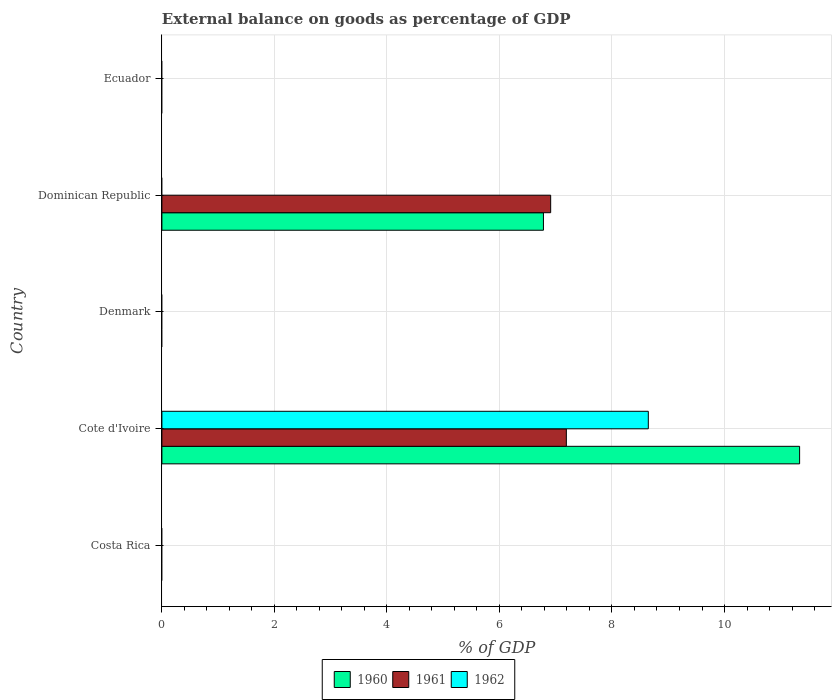How many different coloured bars are there?
Keep it short and to the point. 3. Are the number of bars per tick equal to the number of legend labels?
Ensure brevity in your answer.  No. What is the label of the 1st group of bars from the top?
Provide a succinct answer. Ecuador. In how many cases, is the number of bars for a given country not equal to the number of legend labels?
Your answer should be compact. 4. Across all countries, what is the maximum external balance on goods as percentage of GDP in 1961?
Ensure brevity in your answer.  7.19. Across all countries, what is the minimum external balance on goods as percentage of GDP in 1962?
Offer a very short reply. 0. In which country was the external balance on goods as percentage of GDP in 1961 maximum?
Provide a short and direct response. Cote d'Ivoire. What is the total external balance on goods as percentage of GDP in 1962 in the graph?
Your answer should be compact. 8.65. What is the difference between the external balance on goods as percentage of GDP in 1960 in Cote d'Ivoire and that in Dominican Republic?
Make the answer very short. 4.55. What is the difference between the external balance on goods as percentage of GDP in 1962 in Ecuador and the external balance on goods as percentage of GDP in 1961 in Dominican Republic?
Offer a terse response. -6.91. What is the average external balance on goods as percentage of GDP in 1962 per country?
Give a very brief answer. 1.73. What is the difference between the external balance on goods as percentage of GDP in 1962 and external balance on goods as percentage of GDP in 1961 in Cote d'Ivoire?
Provide a succinct answer. 1.46. In how many countries, is the external balance on goods as percentage of GDP in 1962 greater than 8 %?
Make the answer very short. 1. What is the difference between the highest and the lowest external balance on goods as percentage of GDP in 1960?
Your response must be concise. 11.34. How many bars are there?
Keep it short and to the point. 5. How many countries are there in the graph?
Provide a succinct answer. 5. Does the graph contain any zero values?
Keep it short and to the point. Yes. Does the graph contain grids?
Give a very brief answer. Yes. How are the legend labels stacked?
Provide a short and direct response. Horizontal. What is the title of the graph?
Provide a short and direct response. External balance on goods as percentage of GDP. Does "1992" appear as one of the legend labels in the graph?
Offer a terse response. No. What is the label or title of the X-axis?
Your response must be concise. % of GDP. What is the % of GDP in 1960 in Costa Rica?
Your response must be concise. 0. What is the % of GDP in 1962 in Costa Rica?
Your answer should be very brief. 0. What is the % of GDP in 1960 in Cote d'Ivoire?
Your answer should be compact. 11.34. What is the % of GDP in 1961 in Cote d'Ivoire?
Make the answer very short. 7.19. What is the % of GDP in 1962 in Cote d'Ivoire?
Offer a terse response. 8.65. What is the % of GDP of 1961 in Denmark?
Your answer should be compact. 0. What is the % of GDP in 1960 in Dominican Republic?
Offer a very short reply. 6.78. What is the % of GDP in 1961 in Dominican Republic?
Your answer should be very brief. 6.91. What is the % of GDP of 1962 in Dominican Republic?
Keep it short and to the point. 0. What is the % of GDP of 1962 in Ecuador?
Make the answer very short. 0. Across all countries, what is the maximum % of GDP of 1960?
Offer a terse response. 11.34. Across all countries, what is the maximum % of GDP in 1961?
Make the answer very short. 7.19. Across all countries, what is the maximum % of GDP in 1962?
Your response must be concise. 8.65. What is the total % of GDP in 1960 in the graph?
Make the answer very short. 18.12. What is the total % of GDP in 1961 in the graph?
Offer a terse response. 14.1. What is the total % of GDP in 1962 in the graph?
Offer a very short reply. 8.65. What is the difference between the % of GDP of 1960 in Cote d'Ivoire and that in Dominican Republic?
Your answer should be very brief. 4.55. What is the difference between the % of GDP in 1961 in Cote d'Ivoire and that in Dominican Republic?
Make the answer very short. 0.28. What is the difference between the % of GDP of 1960 in Cote d'Ivoire and the % of GDP of 1961 in Dominican Republic?
Your answer should be compact. 4.42. What is the average % of GDP in 1960 per country?
Provide a succinct answer. 3.62. What is the average % of GDP of 1961 per country?
Your answer should be compact. 2.82. What is the average % of GDP in 1962 per country?
Give a very brief answer. 1.73. What is the difference between the % of GDP of 1960 and % of GDP of 1961 in Cote d'Ivoire?
Give a very brief answer. 4.15. What is the difference between the % of GDP of 1960 and % of GDP of 1962 in Cote d'Ivoire?
Your answer should be compact. 2.69. What is the difference between the % of GDP of 1961 and % of GDP of 1962 in Cote d'Ivoire?
Offer a very short reply. -1.46. What is the difference between the % of GDP in 1960 and % of GDP in 1961 in Dominican Republic?
Ensure brevity in your answer.  -0.13. What is the ratio of the % of GDP in 1960 in Cote d'Ivoire to that in Dominican Republic?
Your answer should be very brief. 1.67. What is the ratio of the % of GDP in 1961 in Cote d'Ivoire to that in Dominican Republic?
Provide a succinct answer. 1.04. What is the difference between the highest and the lowest % of GDP in 1960?
Your response must be concise. 11.34. What is the difference between the highest and the lowest % of GDP in 1961?
Ensure brevity in your answer.  7.19. What is the difference between the highest and the lowest % of GDP in 1962?
Your response must be concise. 8.65. 